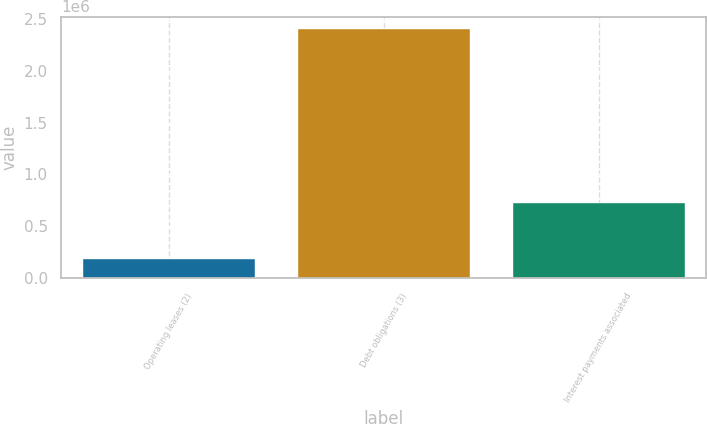<chart> <loc_0><loc_0><loc_500><loc_500><bar_chart><fcel>Operating leases (2)<fcel>Debt obligations (3)<fcel>Interest payments associated<nl><fcel>190171<fcel>2.4e+06<fcel>724900<nl></chart> 